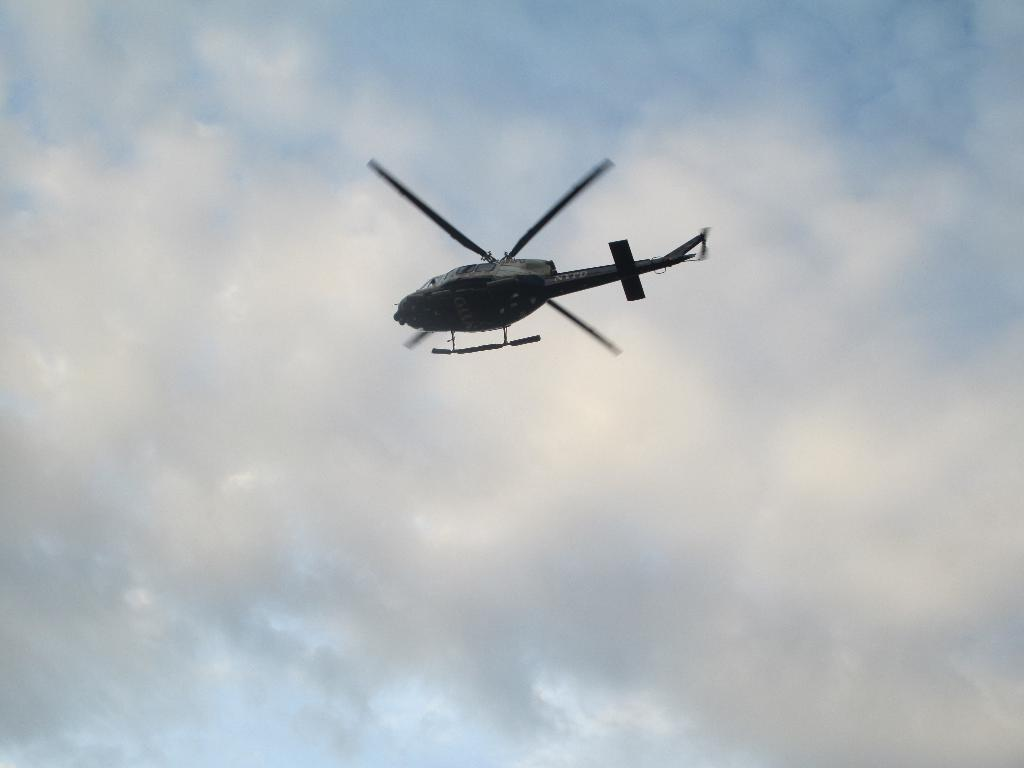What is the main subject of the image? The main subject of the image is a helicopter. What is the helicopter doing in the image? The helicopter is flying in the sky. What else can be seen in the sky in the image? Clouds are visible in the sky. Can you see any snails crawling on the helicopter in the image? There are no snails visible on the helicopter in the image. Is there any lettuce growing on the helicopter in the image? There is no lettuce present on the helicopter in the image. 